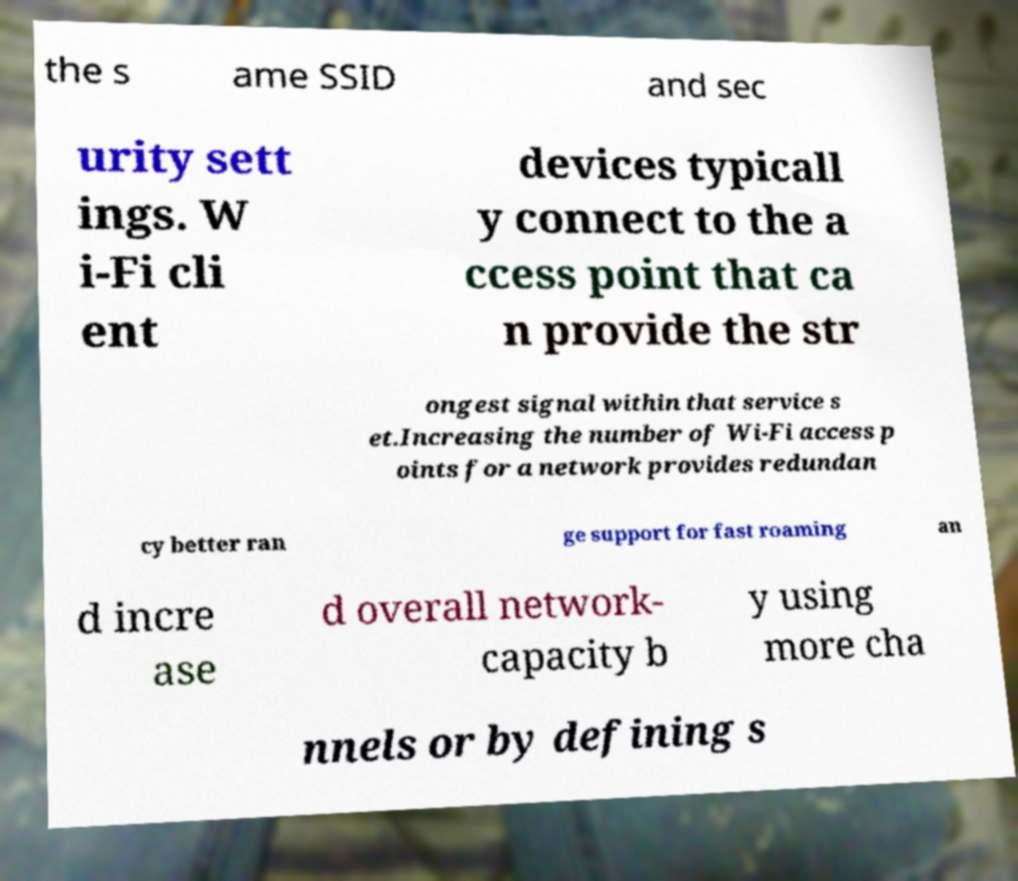What messages or text are displayed in this image? I need them in a readable, typed format. the s ame SSID and sec urity sett ings. W i-Fi cli ent devices typicall y connect to the a ccess point that ca n provide the str ongest signal within that service s et.Increasing the number of Wi-Fi access p oints for a network provides redundan cy better ran ge support for fast roaming an d incre ase d overall network- capacity b y using more cha nnels or by defining s 